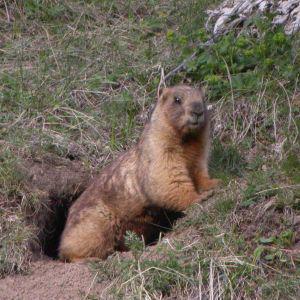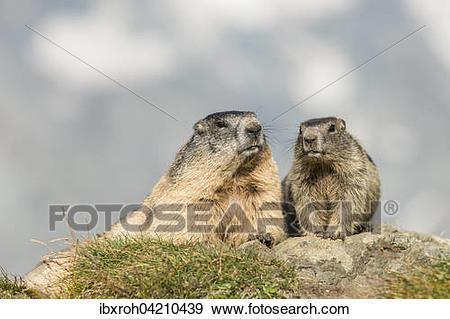The first image is the image on the left, the second image is the image on the right. For the images shown, is this caption "There are three marmots" true? Answer yes or no. Yes. The first image is the image on the left, the second image is the image on the right. For the images shown, is this caption "There is three rodents." true? Answer yes or no. Yes. 